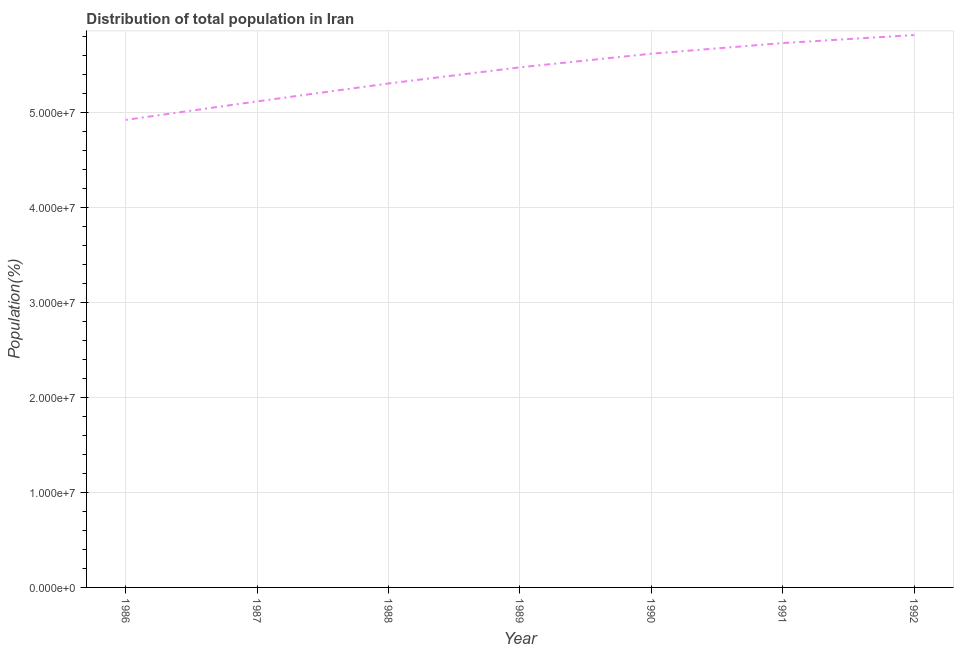What is the population in 1991?
Ensure brevity in your answer.  5.73e+07. Across all years, what is the maximum population?
Your answer should be compact. 5.81e+07. Across all years, what is the minimum population?
Your answer should be very brief. 4.92e+07. In which year was the population minimum?
Give a very brief answer. 1986. What is the sum of the population?
Provide a succinct answer. 3.80e+08. What is the difference between the population in 1991 and 1992?
Make the answer very short. -8.42e+05. What is the average population per year?
Offer a very short reply. 5.42e+07. What is the median population?
Offer a very short reply. 5.47e+07. What is the ratio of the population in 1986 to that in 1992?
Provide a succinct answer. 0.85. Is the population in 1988 less than that in 1992?
Offer a terse response. Yes. What is the difference between the highest and the second highest population?
Offer a very short reply. 8.42e+05. Is the sum of the population in 1986 and 1992 greater than the maximum population across all years?
Ensure brevity in your answer.  Yes. What is the difference between the highest and the lowest population?
Make the answer very short. 8.92e+06. How many years are there in the graph?
Ensure brevity in your answer.  7. Are the values on the major ticks of Y-axis written in scientific E-notation?
Offer a terse response. Yes. Does the graph contain any zero values?
Keep it short and to the point. No. Does the graph contain grids?
Ensure brevity in your answer.  Yes. What is the title of the graph?
Provide a succinct answer. Distribution of total population in Iran . What is the label or title of the Y-axis?
Give a very brief answer. Population(%). What is the Population(%) of 1986?
Ensure brevity in your answer.  4.92e+07. What is the Population(%) of 1987?
Offer a terse response. 5.12e+07. What is the Population(%) in 1988?
Provide a succinct answer. 5.30e+07. What is the Population(%) of 1989?
Your response must be concise. 5.47e+07. What is the Population(%) in 1990?
Provide a short and direct response. 5.62e+07. What is the Population(%) of 1991?
Offer a terse response. 5.73e+07. What is the Population(%) in 1992?
Your answer should be compact. 5.81e+07. What is the difference between the Population(%) in 1986 and 1987?
Ensure brevity in your answer.  -1.95e+06. What is the difference between the Population(%) in 1986 and 1988?
Your response must be concise. -3.83e+06. What is the difference between the Population(%) in 1986 and 1989?
Provide a succinct answer. -5.53e+06. What is the difference between the Population(%) in 1986 and 1990?
Give a very brief answer. -6.96e+06. What is the difference between the Population(%) in 1986 and 1991?
Give a very brief answer. -8.08e+06. What is the difference between the Population(%) in 1986 and 1992?
Ensure brevity in your answer.  -8.92e+06. What is the difference between the Population(%) in 1987 and 1988?
Provide a succinct answer. -1.88e+06. What is the difference between the Population(%) in 1987 and 1989?
Your answer should be very brief. -3.58e+06. What is the difference between the Population(%) in 1987 and 1990?
Your response must be concise. -5.02e+06. What is the difference between the Population(%) in 1987 and 1991?
Offer a very short reply. -6.14e+06. What is the difference between the Population(%) in 1987 and 1992?
Provide a short and direct response. -6.98e+06. What is the difference between the Population(%) in 1988 and 1989?
Offer a very short reply. -1.70e+06. What is the difference between the Population(%) in 1988 and 1990?
Your response must be concise. -3.13e+06. What is the difference between the Population(%) in 1988 and 1991?
Provide a succinct answer. -4.25e+06. What is the difference between the Population(%) in 1988 and 1992?
Give a very brief answer. -5.09e+06. What is the difference between the Population(%) in 1989 and 1990?
Give a very brief answer. -1.43e+06. What is the difference between the Population(%) in 1989 and 1991?
Ensure brevity in your answer.  -2.55e+06. What is the difference between the Population(%) in 1989 and 1992?
Your response must be concise. -3.39e+06. What is the difference between the Population(%) in 1990 and 1991?
Provide a succinct answer. -1.12e+06. What is the difference between the Population(%) in 1990 and 1992?
Ensure brevity in your answer.  -1.96e+06. What is the difference between the Population(%) in 1991 and 1992?
Provide a short and direct response. -8.42e+05. What is the ratio of the Population(%) in 1986 to that in 1987?
Offer a very short reply. 0.96. What is the ratio of the Population(%) in 1986 to that in 1988?
Your answer should be compact. 0.93. What is the ratio of the Population(%) in 1986 to that in 1989?
Provide a succinct answer. 0.9. What is the ratio of the Population(%) in 1986 to that in 1990?
Offer a very short reply. 0.88. What is the ratio of the Population(%) in 1986 to that in 1991?
Your answer should be very brief. 0.86. What is the ratio of the Population(%) in 1986 to that in 1992?
Your answer should be very brief. 0.85. What is the ratio of the Population(%) in 1987 to that in 1989?
Give a very brief answer. 0.94. What is the ratio of the Population(%) in 1987 to that in 1990?
Offer a very short reply. 0.91. What is the ratio of the Population(%) in 1987 to that in 1991?
Your answer should be very brief. 0.89. What is the ratio of the Population(%) in 1987 to that in 1992?
Give a very brief answer. 0.88. What is the ratio of the Population(%) in 1988 to that in 1989?
Your answer should be compact. 0.97. What is the ratio of the Population(%) in 1988 to that in 1990?
Ensure brevity in your answer.  0.94. What is the ratio of the Population(%) in 1988 to that in 1991?
Your answer should be compact. 0.93. What is the ratio of the Population(%) in 1988 to that in 1992?
Give a very brief answer. 0.91. What is the ratio of the Population(%) in 1989 to that in 1990?
Give a very brief answer. 0.97. What is the ratio of the Population(%) in 1989 to that in 1991?
Provide a short and direct response. 0.95. What is the ratio of the Population(%) in 1989 to that in 1992?
Your answer should be very brief. 0.94. What is the ratio of the Population(%) in 1991 to that in 1992?
Your response must be concise. 0.99. 